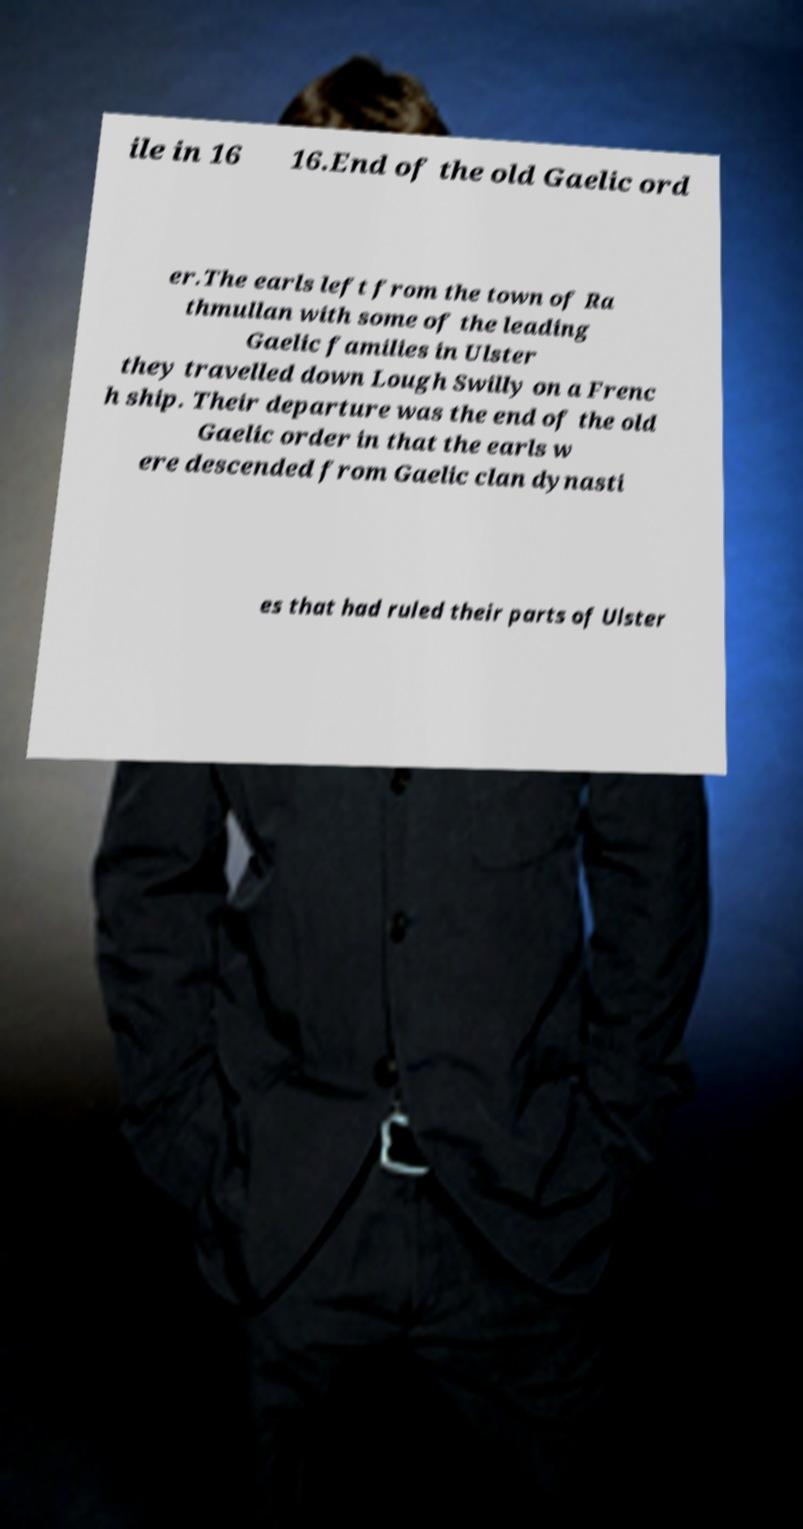Could you assist in decoding the text presented in this image and type it out clearly? ile in 16 16.End of the old Gaelic ord er.The earls left from the town of Ra thmullan with some of the leading Gaelic families in Ulster they travelled down Lough Swilly on a Frenc h ship. Their departure was the end of the old Gaelic order in that the earls w ere descended from Gaelic clan dynasti es that had ruled their parts of Ulster 